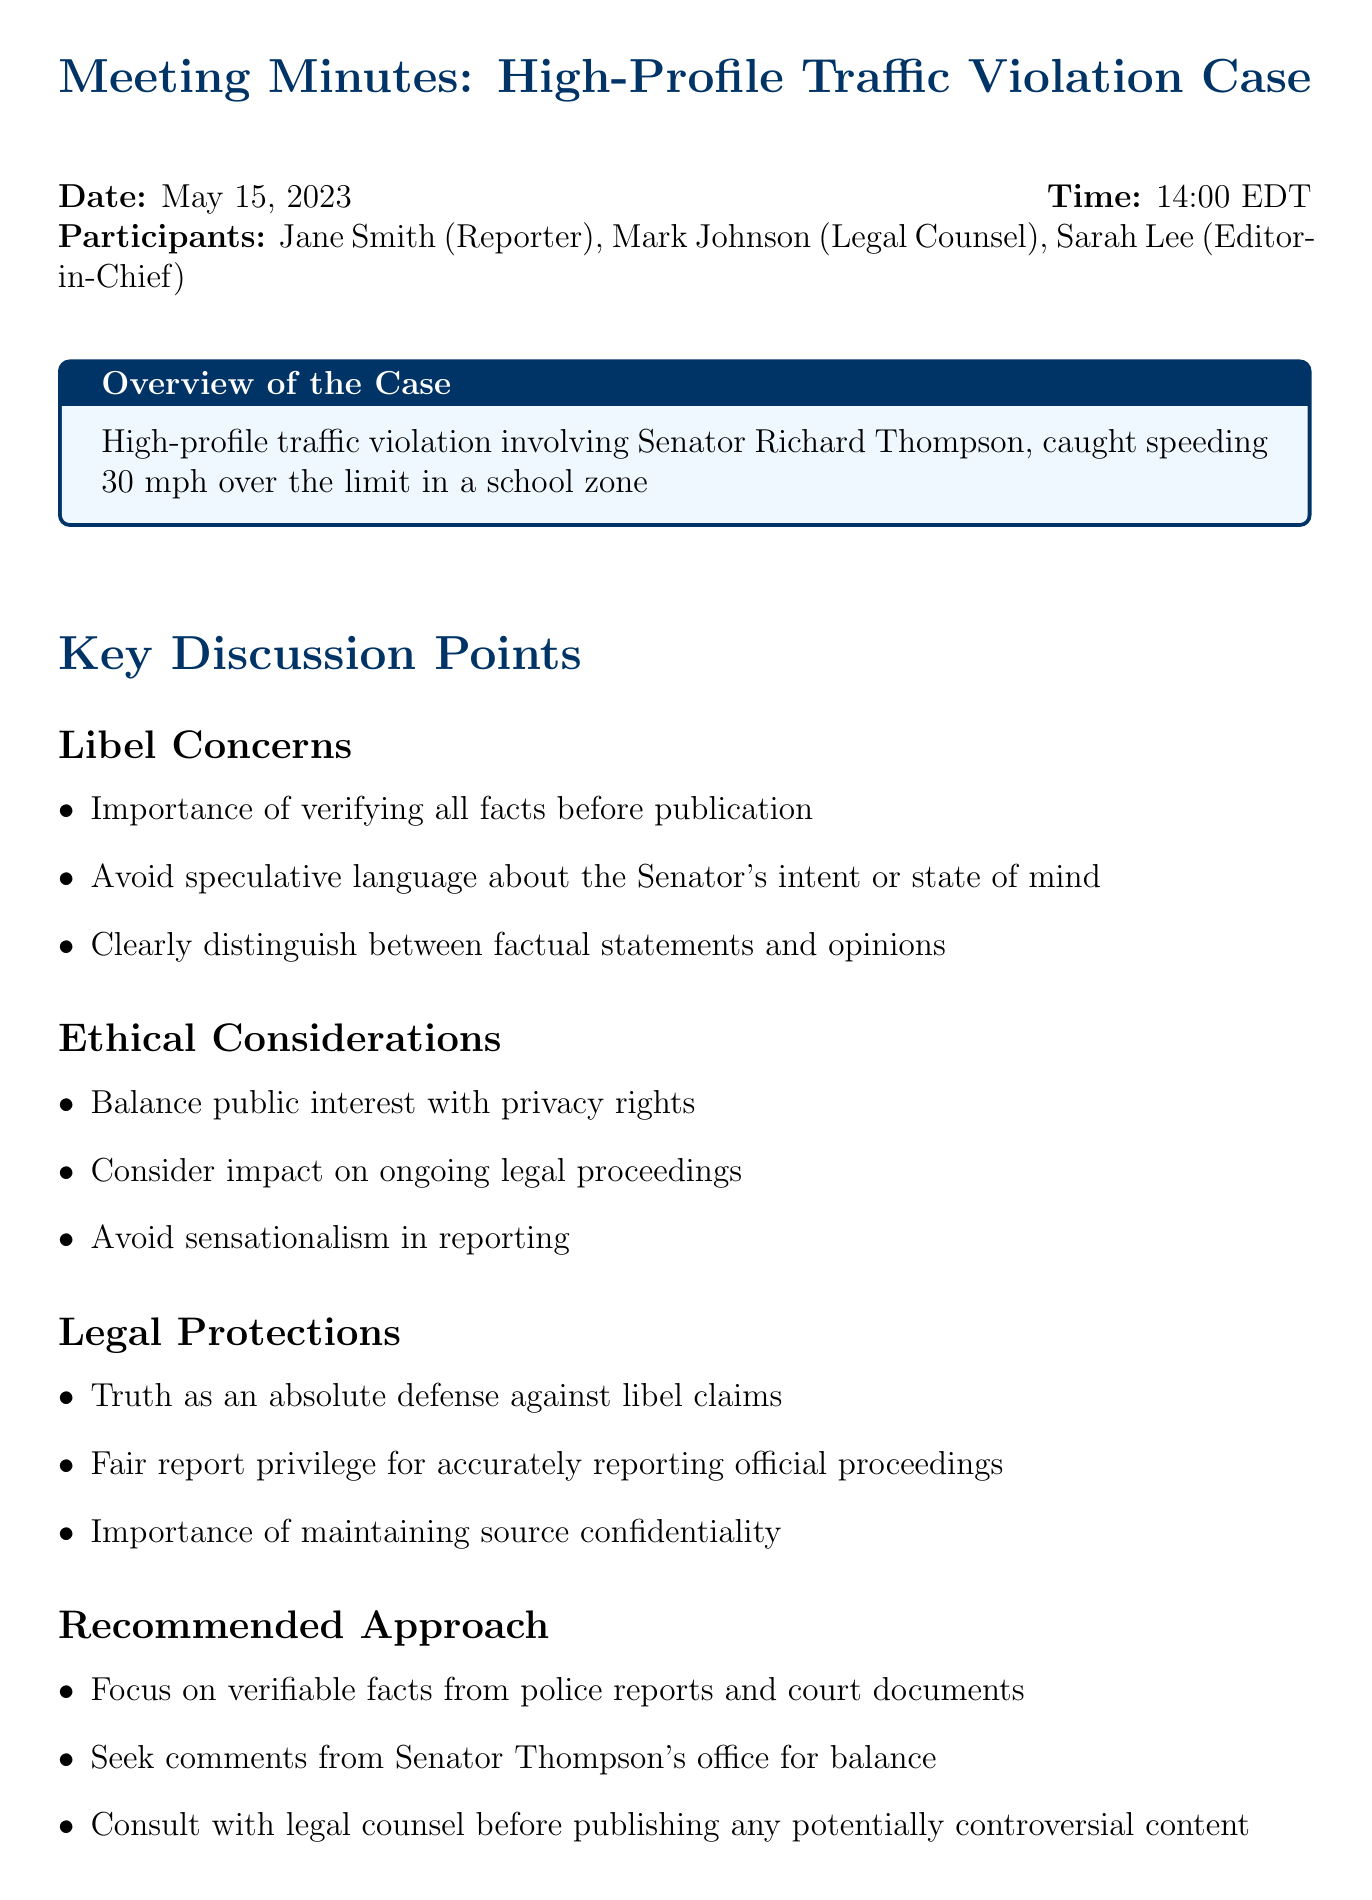What is the date of the meeting? The date of the meeting is stated clearly at the top of the document under meeting details.
Answer: May 15, 2023 Who is the legal counsel present in the meeting? The document lists participants, including the legal counsel, under meeting details.
Answer: Mark Johnson What is the main topic discussed regarding libel concerns? The agenda item outlines key points under libel concerns, which are summarized in bullet points.
Answer: Importance of verifying all facts before publication What is one ethical consideration mentioned in the discussion? Ethical considerations are listed as part of the agenda items, detailing key points of discussion.
Answer: Balance public interest with privacy rights What is mentioned as an absolute defense against libel claims? The document discusses legal protections, specifically highlighting key points relevant to libel.
Answer: Truth What action item is assigned to Jane? Action items provide a list of tasks assigned to participants of the meeting.
Answer: Jane to obtain official police report and court filings What is one recommended approach for reporting on the case? The recommended approach section outlines steps to take in reporting, providing clear directives.
Answer: Focus on verifiable facts from police reports and court documents What is the purpose of consulting with legal counsel before publishing? The document mentions consulting legal counsel in the context of the recommended approach, giving reasons for this action.
Answer: Avoid potentially controversial content 